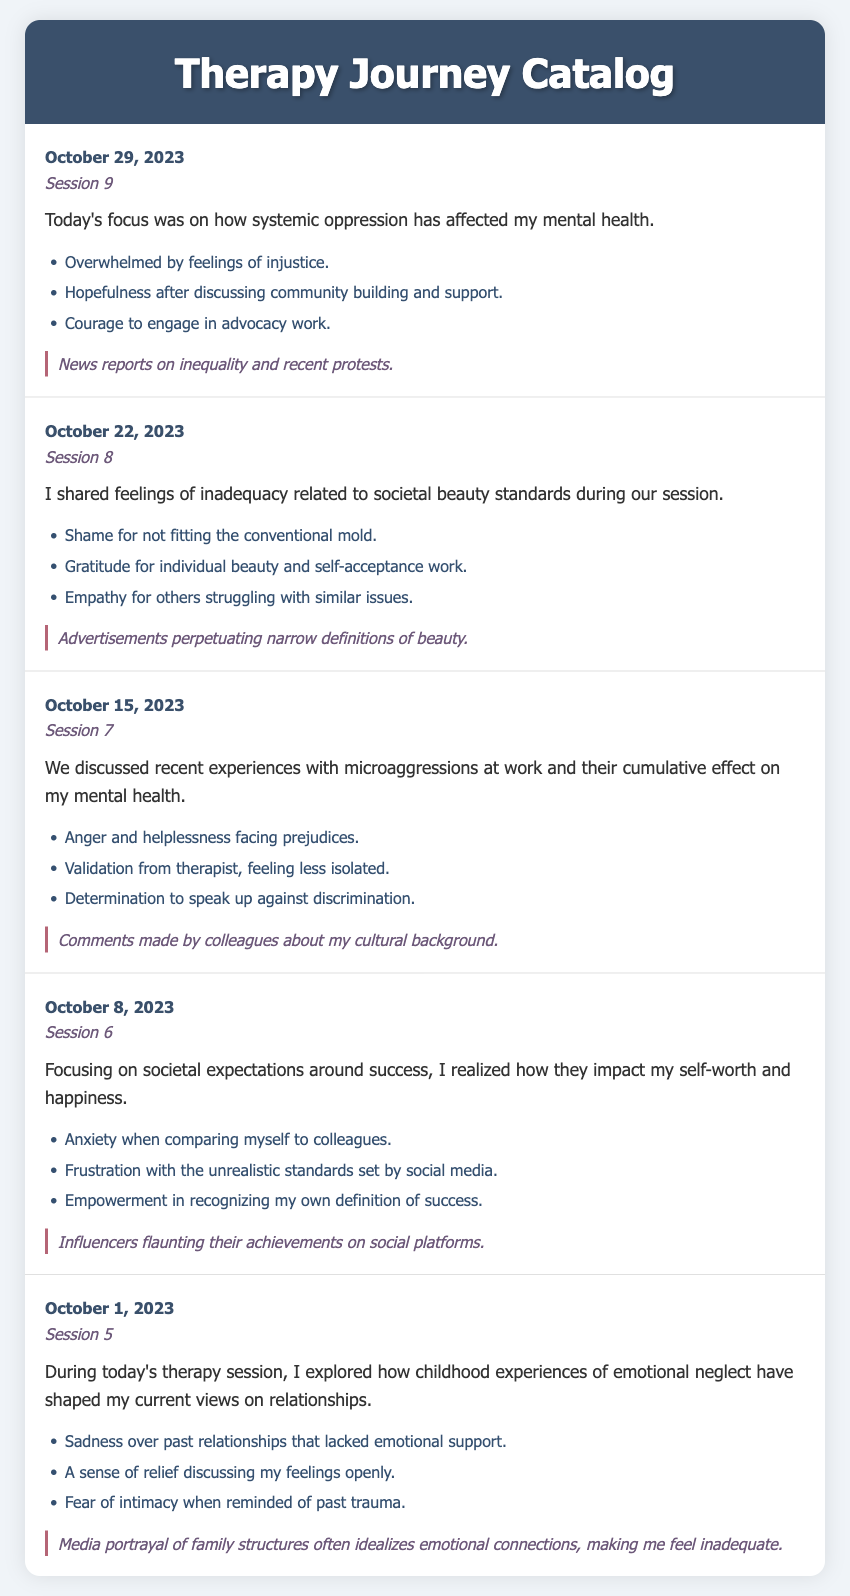What is the date of Session 9? The date listed for Session 9 in the document is October 29, 2023.
Answer: October 29, 2023 What was a societal trigger in Session 8? The societal trigger mentioned during Session 8 relates to advertisements perpetuating narrow definitions of beauty.
Answer: Advertisements perpetuating narrow definitions of beauty How many emotional responses were listed for Session 5? The emotional responses listed for Session 5 are three in total based on the document structure.
Answer: Three What feeling was discussed in relation to societal beauty standards? The feeling of shame for not fitting the conventional mold was discussed during the session.
Answer: Shame In which session were microaggressions at work addressed? Microaggressions at work were addressed in Session 7 according to the catalog entries.
Answer: Session 7 What did the therapist's validation in Session 7 lead to? The validation from the therapist helped the individual feel less isolated regarding their experiences.
Answer: Less isolated What is the main theme of the summary in Session 6? The main theme of the summary in Session 6 revolves around societal expectations around success.
Answer: Societal expectations around success Which session discussed the impact of childhood experiences on relationships? The impact of childhood experiences of emotional neglect on relationships was discussed in Session 5.
Answer: Session 5 